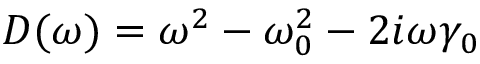Convert formula to latex. <formula><loc_0><loc_0><loc_500><loc_500>D ( \omega ) = \omega ^ { 2 } - \omega _ { 0 } ^ { 2 } - 2 i \omega \gamma _ { 0 }</formula> 